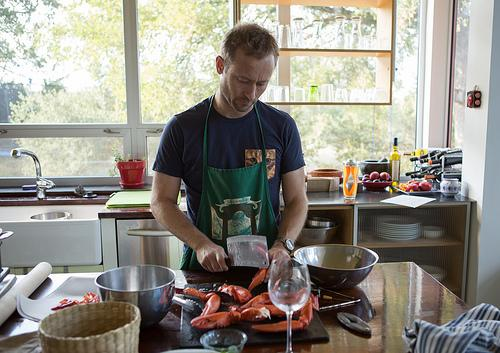Describe the location and appearance of the bowl in the image. A stainless steel bowl is on the work island, positioned next to the man's arm. What is the man holding in his hand and what is he doing with it? The man is holding a meat cleaver and using it to chop a lobster. Identify the color of the shirt the man is wearing and what object is on it. The man is wearing a blue shirt with a cat on the shirt pocket. List two items found on the kitchen counter. Red tomatoes and an empty wine glass are on the kitchen counter. Describe the scene visible through the window. Trees can be seen outside the window, capturing the outdoor environment. What type of accessory does the man have on his left wrist? The man has a watch on his left wrist. What is the color of the apron worn by the man and what type of plant is nearby? The man is wearing a green apron, and there is a scraggly plant in an orange flower pot nearby. Explain where the wine rack can be found and its contents. The wine rack is near the window and filled with bottles of wine. What is located on the cutting board, and what action is being performed on it? A lobster is laying on the cutting board, and the man is cracking its lobster claw. Identify the type of glass on the counter and its position in relation to other objects. There is an empty wine glass on the counter in the foreground of the image. Based on the image, is the man left-handed or right-handed? The man could be using either hand, it is not possible to determine with certainty. Create a visual and textual narrative inspired by the image. As the sun sets gently, casting warm light through the kitchen window, the scent of fresh lobster fills the air. A chef, his wrist adorned with a watch, skillfully wields his cleaver, preparing a mouth-watering feast. The counter, a stage for culinary masterpieces, is laden with an array of ingredients and instruments – fresh, ripe tomatoes, and shiny stainless steel bowls, all awaiting their call to glory. Are there green tomatoes on the counter near the basket? This is misleading because the tomatoes are red, not green. What color is the man's shirt in the image? Blue Which of these objects is not present in the image? A) watch B) sunglasses C) wine glass D) meat cleaver B) sunglasses Where is the dog sitting on the kitchen floor and help the man? This instruction is misleading because there is no dog mentioned in the image; there's a cat on the shirt pocket instead. Notice the woman helping the man in the kitchen by holding a spatula. This is misleading because there's no mention of a woman or a spatula in the image; only a man is mentioned. What cooking task is the man performing in the image? The man is chopping a lobster. Identify any text visible in the image. There is no visible text in the image. Analyze the facial features of any person present in the image. The facial features of the person cannot be analyzed as his face is not visible in the image. Find the man wearing a purple shirt and red apron in the kitchen. This instruction is misleading because the man is actually wearing a blue shirt and green apron. Can you confirm if the man is wearing a watch? If so, on which wrist? Yes, he is wearing a watch on his left wrist. Explain how various kitchen appliances, ingredients, and utensils are organized and structured in relation to each other in the image. The man is the central focus, with different appliances, ingredients, and utensils like the cutting board, tomatoes, stainless steel bowl, and wine glass around him. The wine rack and potted plant are placed by the window, creating a visually balanced distribution of elements. Describe the stainless steel bowl located in the image. The stainless steel bowl is placed on the work island, with its reflective surface catching the light from the surrounding environment. What is the main activity depicted in the image? Man chopping a lobster in the kitchen. Is the man trying to cut the lobster using a regular kitchen knife? This is misleading because the man is actually using a meat cleaver, not a regular kitchen knife. Can you find a checkered kitchen towel hanging by the sink? This is misleading because the towel is striped, not checkered, and it's on the counter, not hanging by the sink. Analyze and describe the organization and structure of the objects in the image. The central focus is the man chopping the lobster on the counter, surrounded by various kitchen utensils, appliances and ingredients such as a stainless steel bowl, wine glass, cutting board, tongs, tomatoes, a potted plant, a basket, and a wine rack by the window. Can you see the orange juice next to the empty wine glass on the counter? This is misleading because there is no mention of orange juice in the image; there's only an empty wine glass on the counter. Identify the yellow flower pot containing a well-groomed plant by the window. This is misleading because the flower pot is orange, not yellow, and the plant is described as scraggly, not well-groomed. Describe the scene in the image using a vivid and poetic language. A culinary maestro clad in a vibrant blue shirt and emerald apron, artfully wields an inverted cleaver upon a succulent lobster, while time ticks on his left wrist, and a verdant potted plant basks in the gentle sun's embrace. Identify any significant ongoing activity or event in the image. No significant ongoing activity or event is identified. Locate the plastic bowl next to the man's arm on the work island. This is misleading because the bowl is made of stainless steel, not plastic. Is there any specific event being held or detected in the image? No, there is no specific event detected in the image. Are there any visible numbers or letters in the image? No, there are no visible numbers or letters in the image. What is the man using to chop the lobster in the image? The man is using an upside-down meat cleaver to chop the lobster. Does the man have a digital watch on his right wrist while he cooks the lobster? This is misleading because the man has a watch on his left wrist, not his right, and the type of watch is not specified. Please provide a succinct and factual description of the scene captured in the image. A man wearing a blue shirt, green apron, and a watch is chopping a lobster on a kitchen counter surrounded by various utensils and items such as a stainless steel bowl, wine glass, and a basket. 